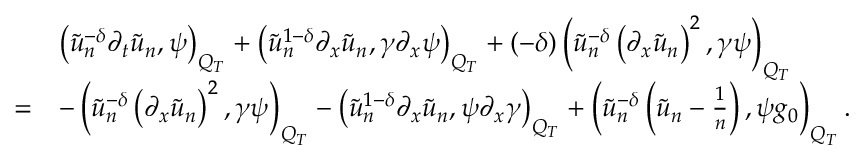Convert formula to latex. <formula><loc_0><loc_0><loc_500><loc_500>\begin{array} { r l } & { \left ( \tilde { u } _ { n } ^ { - \delta } \partial _ { t } \tilde { u } _ { n } , \psi \right ) _ { Q _ { T } } + \left ( \tilde { u } _ { n } ^ { 1 - \delta } \partial _ { x } \tilde { u } _ { n } , \gamma \partial _ { x } \psi \right ) _ { Q _ { T } } + ( - \delta ) \left ( \tilde { u } _ { n } ^ { - \delta } \left ( \partial _ { x } \tilde { u } _ { n } \right ) ^ { 2 } , \gamma \psi \right ) _ { Q _ { T } } } \\ { = } & { - \left ( \tilde { u } _ { n } ^ { - \delta } \left ( \partial _ { x } \tilde { u } _ { n } \right ) ^ { 2 } , \gamma \psi \right ) _ { Q _ { T } } - \left ( \tilde { u } _ { n } ^ { 1 - \delta } \partial _ { x } \tilde { u } _ { n } , \psi \partial _ { x } \gamma \right ) _ { Q _ { T } } + \left ( \tilde { u } _ { n } ^ { - \delta } \left ( \tilde { u } _ { n } - \frac { 1 } { n } \right ) , \psi g _ { 0 } \right ) _ { Q _ { T } } . } \end{array}</formula> 